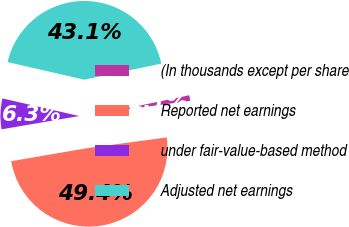<chart> <loc_0><loc_0><loc_500><loc_500><pie_chart><fcel>(In thousands except per share<fcel>Reported net earnings<fcel>under fair-value-based method<fcel>Adjusted net earnings<nl><fcel>1.15%<fcel>49.43%<fcel>6.29%<fcel>43.14%<nl></chart> 